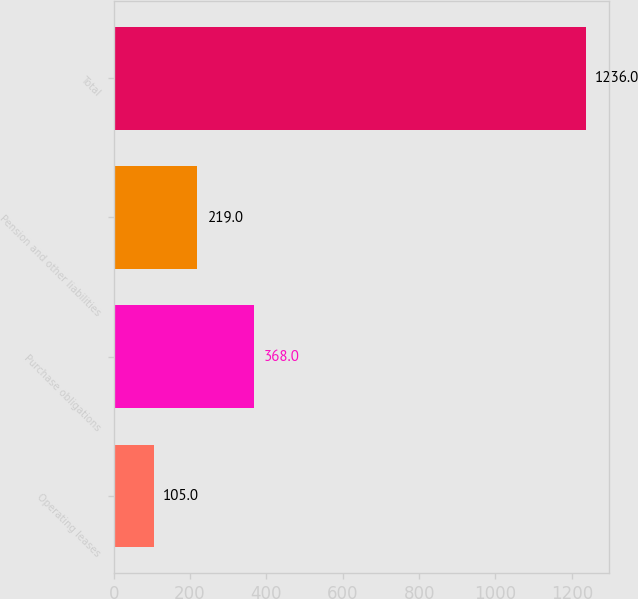Convert chart. <chart><loc_0><loc_0><loc_500><loc_500><bar_chart><fcel>Operating leases<fcel>Purchase obligations<fcel>Pension and other liabilities<fcel>Total<nl><fcel>105<fcel>368<fcel>219<fcel>1236<nl></chart> 